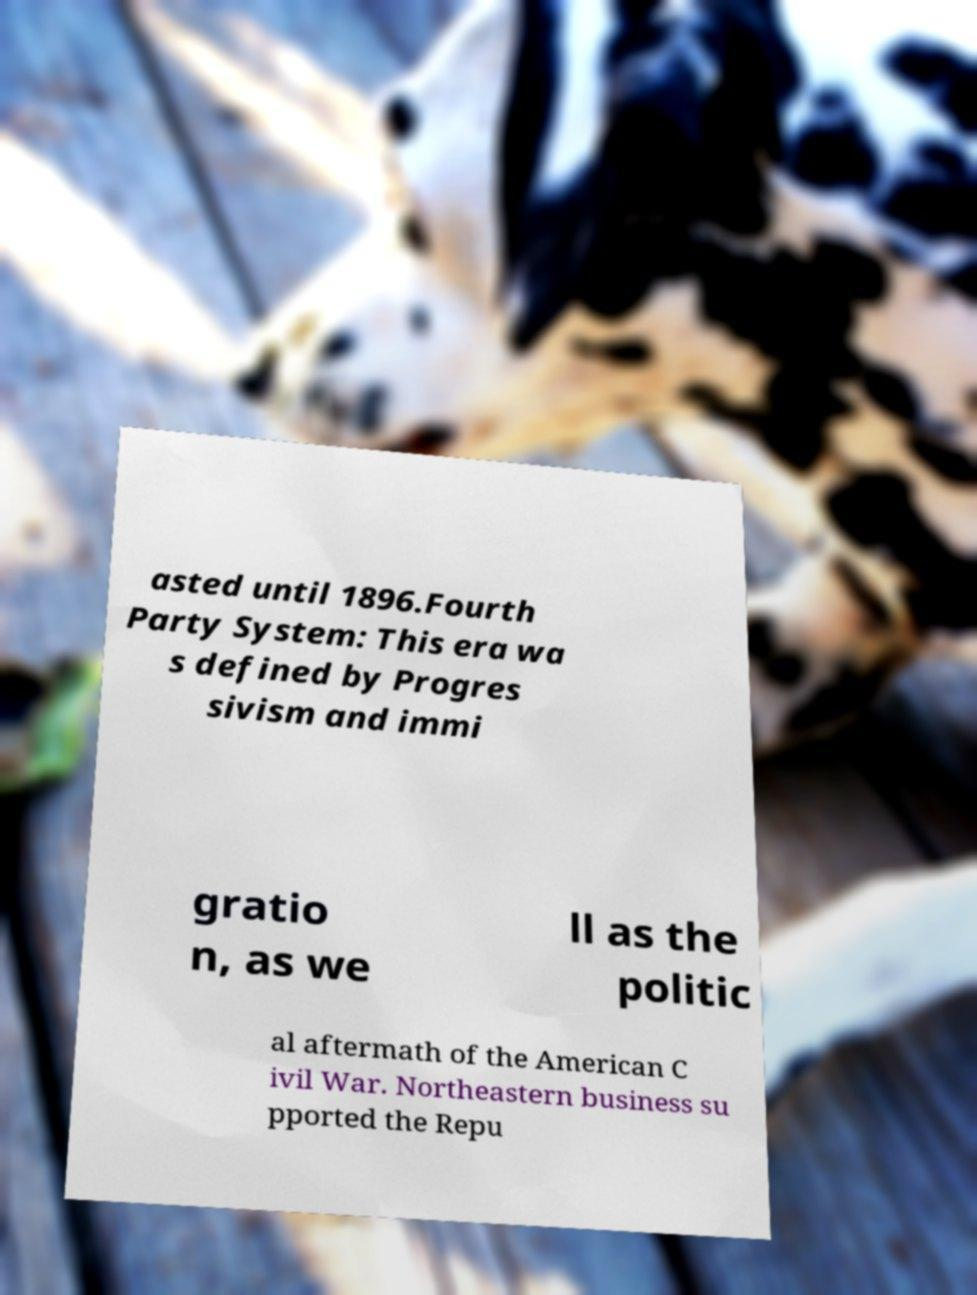Can you accurately transcribe the text from the provided image for me? asted until 1896.Fourth Party System: This era wa s defined by Progres sivism and immi gratio n, as we ll as the politic al aftermath of the American C ivil War. Northeastern business su pported the Repu 